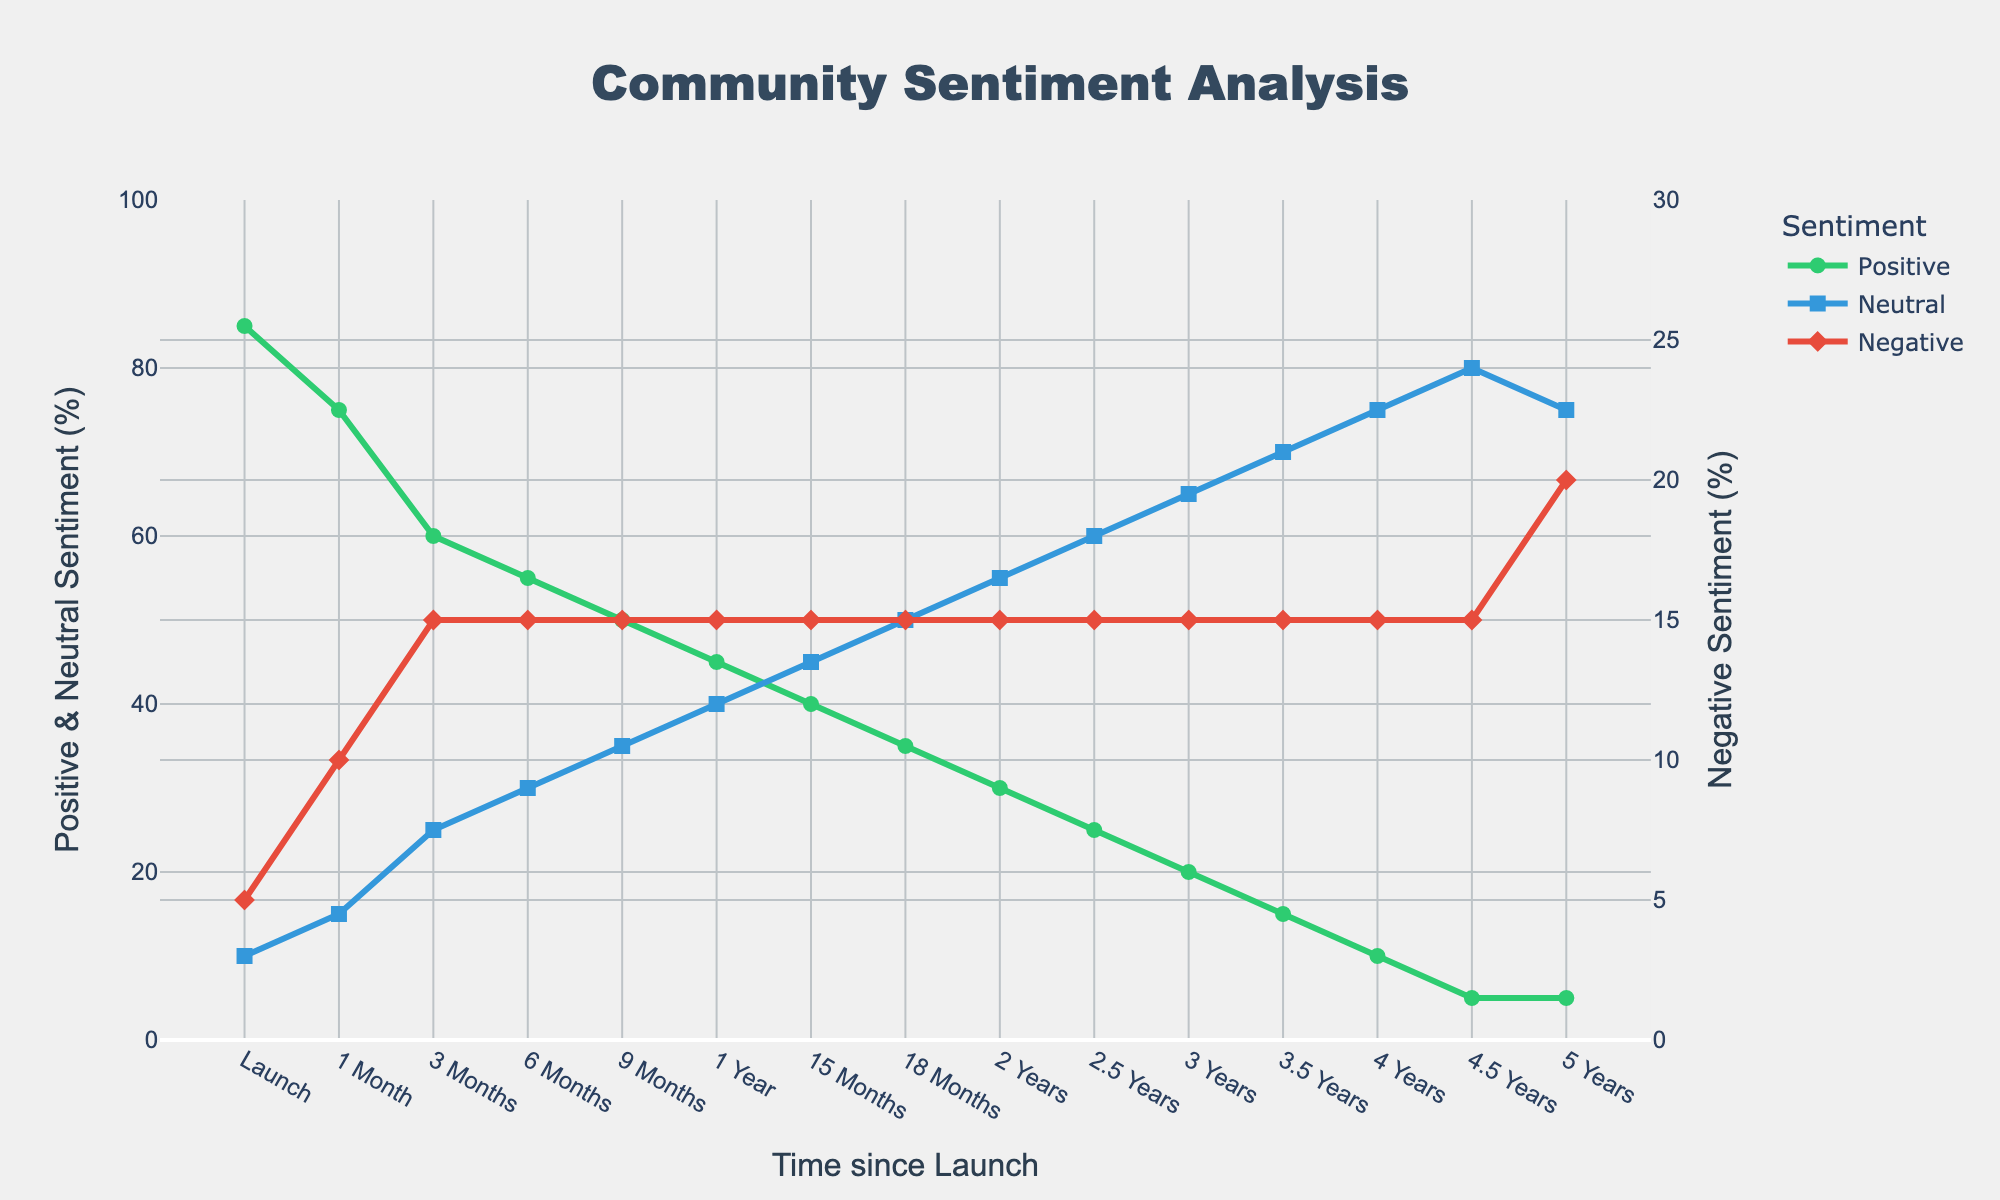Which sentiment had the highest percentage at the game launch? At the game launch, the highest percentage can be identified by looking for the highest point among the sentiments. In this case, it is the "Positive Sentiment" with 85%.
Answer: Positive Sentiment How has the positive sentiment changed from launch to 1 year? To determine the change in positive sentiment from launch to 1 year, subtract the value at 1 year from the launch value. The launch positive sentiment is 85%, and the 1-year positive sentiment is 45%. The change is 85% - 45% = 40%.
Answer: Decreased by 40% What is the total percentage of Neutral and Negative Sentiment at 6 months? To find the total percentage of Neutral and Negative sentiments at 6 months, add the percentages of both sentiments at that time. Neutral Sentiment is 30% and Negative Sentiment is 15%, so the total is 30% + 15% = 45%.
Answer: 45% Which sentiment line shows the most consistent value over time? To find the most consistent value over time, look for the sentiment line with the least variation. The "Negative Sentiment" line remains at 15% for most of the timeline, showing little change.
Answer: Negative Sentiment How much did the neutral sentiment increase from launch to 3 years? To calculate the increase in neutral sentiment from launch to 3 years, subtract the value at the launch from the value at 3 years. At launch, it is 10%, and at 3 years, it is 65%. The increase is 65% - 10% = 55%.
Answer: Increased by 55% What is the difference in neutral sentiment between 2 years and 4 years? To find the difference, subtract the neutral sentiment at 2 years from the neutral sentiment at 4 years. The neutral sentiment at 2 years is 55% and at 4 years is 75%. The difference is 75% - 55% = 20%.
Answer: 20% Which sentiment shows a notable change at 5 years compared to previous years? At 5 years, observe the sentiment that deviates significantly from its previous trend. The "Negative Sentiment" increases from a stable 15% to 20%, which is a notable change.
Answer: Negative Sentiment What can you infer about community sentiment trends based on the graph? Over time, positive sentiment decreases steadily while neutral sentiment increases. Negative sentiment remains relatively stable until 5 years when it shows a slight increase, indicating a shift from positive to neutral sentiments.
Answer: Positive down, Neutral up, Negative stable During which time period did the neutral sentiment surpass the positive sentiment? Identify the period when the neutral sentiment becomes higher than the positive sentiment. This occurs between 1 year and 15 months; neutral sentiment exceeds positive sentiment at 15 months.
Answer: 15 Months Compare the trends of positive and negative sentiments over the game's lifecycle. What pattern do you see? Positive sentiment shows a decreasing trend from 85% at launch to 5% at 5 years, while negative sentiment remains mostly stable around 15%. This reveals a declining positivity in player feedback without much change in negative sentiment until the 5-year mark.
Answer: Positive down, Negative stable 